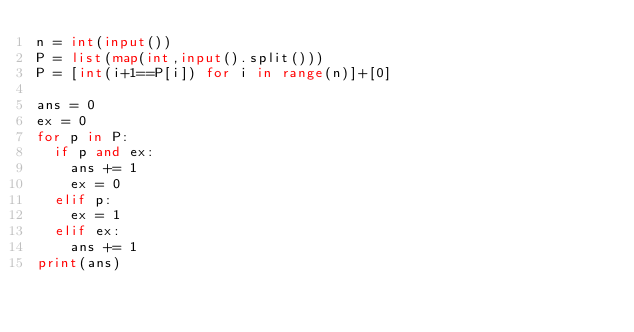<code> <loc_0><loc_0><loc_500><loc_500><_Python_>n = int(input())
P = list(map(int,input().split()))
P = [int(i+1==P[i]) for i in range(n)]+[0]

ans = 0
ex = 0
for p in P:
  if p and ex:
    ans += 1
    ex = 0
  elif p:
    ex = 1
  elif ex:
    ans += 1
print(ans)</code> 